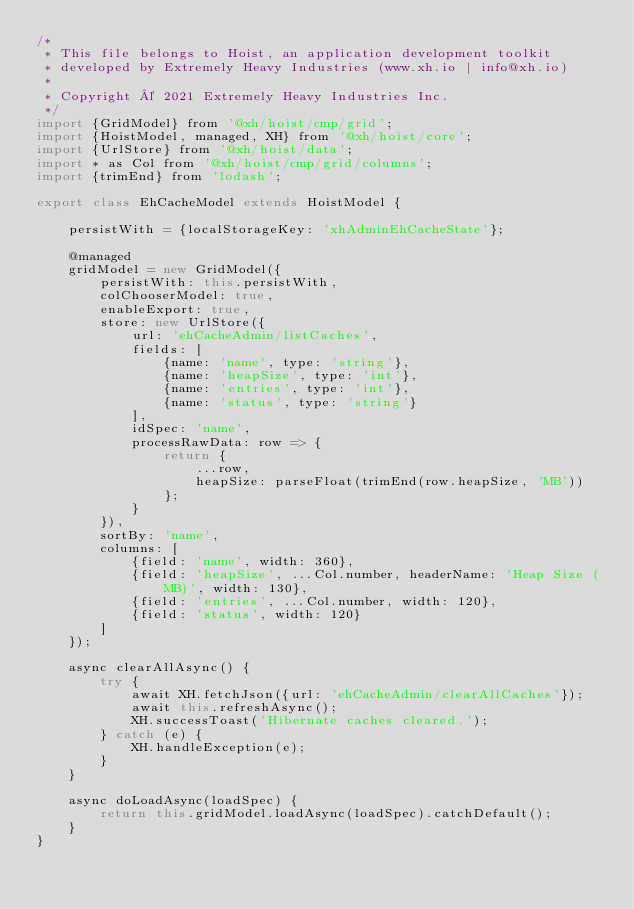Convert code to text. <code><loc_0><loc_0><loc_500><loc_500><_JavaScript_>/*
 * This file belongs to Hoist, an application development toolkit
 * developed by Extremely Heavy Industries (www.xh.io | info@xh.io)
 *
 * Copyright © 2021 Extremely Heavy Industries Inc.
 */
import {GridModel} from '@xh/hoist/cmp/grid';
import {HoistModel, managed, XH} from '@xh/hoist/core';
import {UrlStore} from '@xh/hoist/data';
import * as Col from '@xh/hoist/cmp/grid/columns';
import {trimEnd} from 'lodash';

export class EhCacheModel extends HoistModel {

    persistWith = {localStorageKey: 'xhAdminEhCacheState'};

    @managed
    gridModel = new GridModel({
        persistWith: this.persistWith,
        colChooserModel: true,
        enableExport: true,
        store: new UrlStore({
            url: 'ehCacheAdmin/listCaches',
            fields: [
                {name: 'name', type: 'string'},
                {name: 'heapSize', type: 'int'},
                {name: 'entries', type: 'int'},
                {name: 'status', type: 'string'}
            ],
            idSpec: 'name',
            processRawData: row => {
                return {
                    ...row,
                    heapSize: parseFloat(trimEnd(row.heapSize, 'MB'))
                };
            }
        }),
        sortBy: 'name',
        columns: [
            {field: 'name', width: 360},
            {field: 'heapSize', ...Col.number, headerName: 'Heap Size (MB)', width: 130},
            {field: 'entries', ...Col.number, width: 120},
            {field: 'status', width: 120}
        ]
    });

    async clearAllAsync() {
        try {
            await XH.fetchJson({url: 'ehCacheAdmin/clearAllCaches'});
            await this.refreshAsync();
            XH.successToast('Hibernate caches cleared.');
        } catch (e) {
            XH.handleException(e);
        }
    }

    async doLoadAsync(loadSpec) {
        return this.gridModel.loadAsync(loadSpec).catchDefault();
    }
}


</code> 